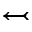<formula> <loc_0><loc_0><loc_500><loc_500>\leftarrow t a i l</formula> 